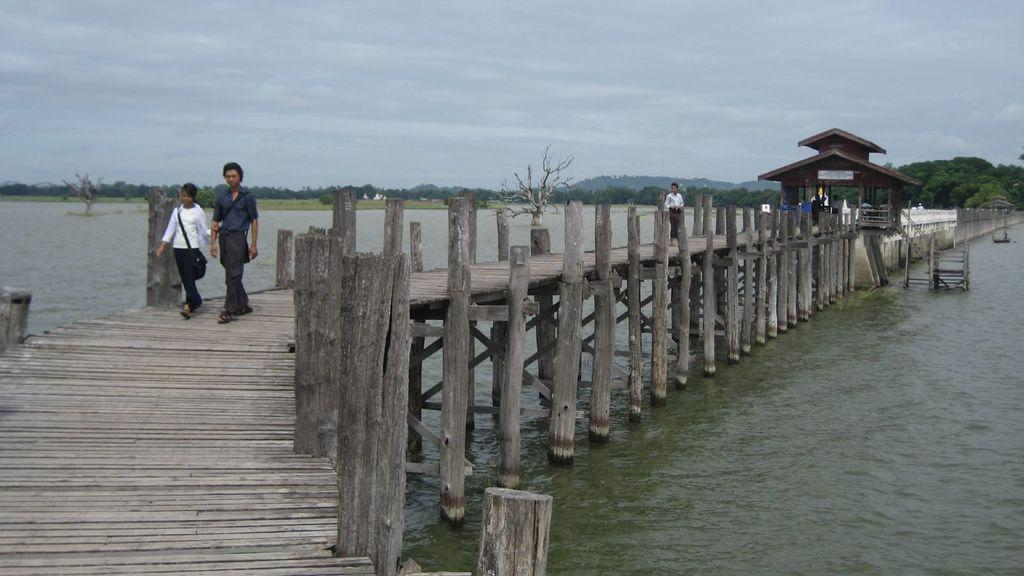What type of structure is present in the image? There is a wooden bridge in the image. What is the bridge situated over? The bridge is over water. What are the people in the image doing? A couple is walking on the bridge. What can be seen in the background of the image? There are many trees in the background of the image. What is visible at the top of the image? The sky is visible at the top of the image. What type of comfort can be seen being offered by the earth in the image? There is no reference to the earth or any comfort being offered in the image. 